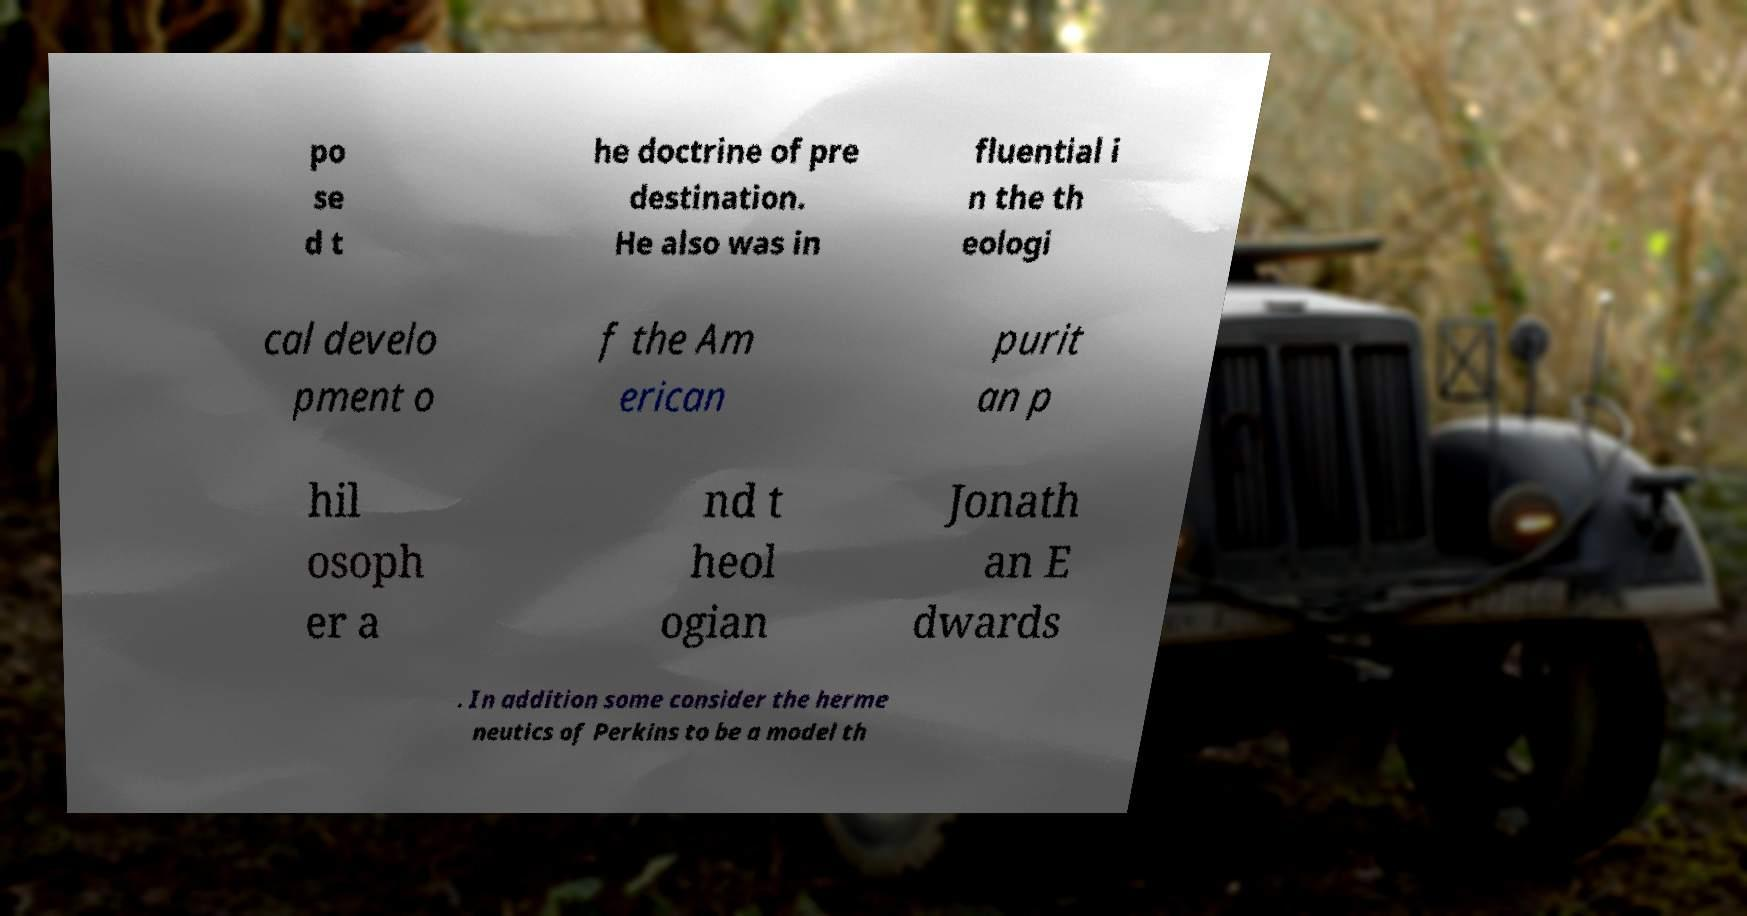For documentation purposes, I need the text within this image transcribed. Could you provide that? po se d t he doctrine of pre destination. He also was in fluential i n the th eologi cal develo pment o f the Am erican purit an p hil osoph er a nd t heol ogian Jonath an E dwards . In addition some consider the herme neutics of Perkins to be a model th 